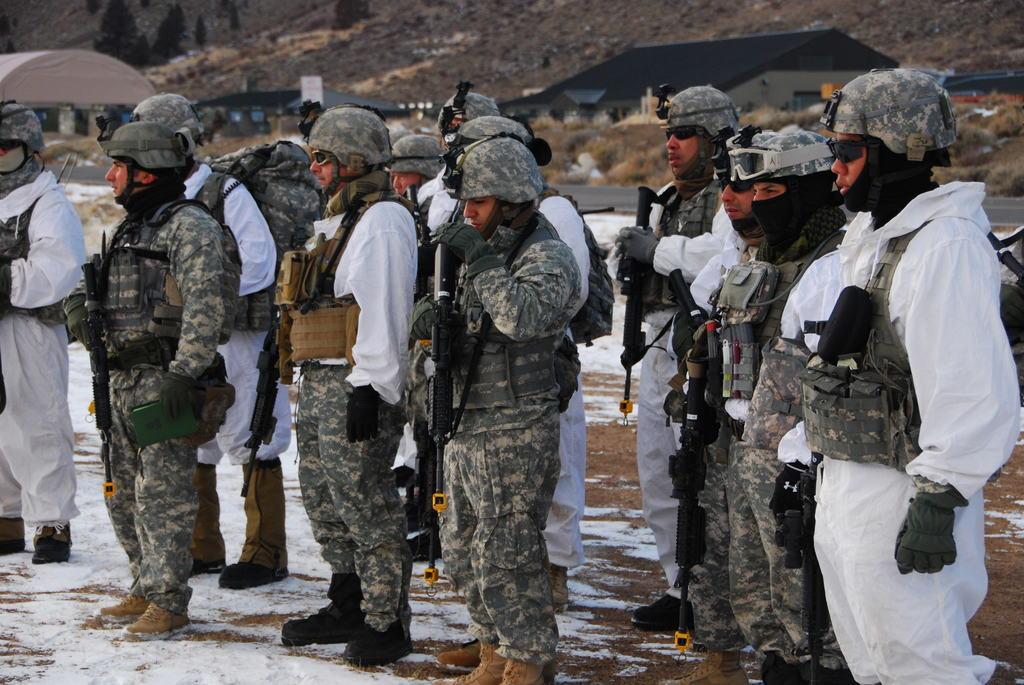Can you describe this image briefly? In this image there are group of people standing and holding the rifles , and in the background there is snow, trees, plants, houses. 